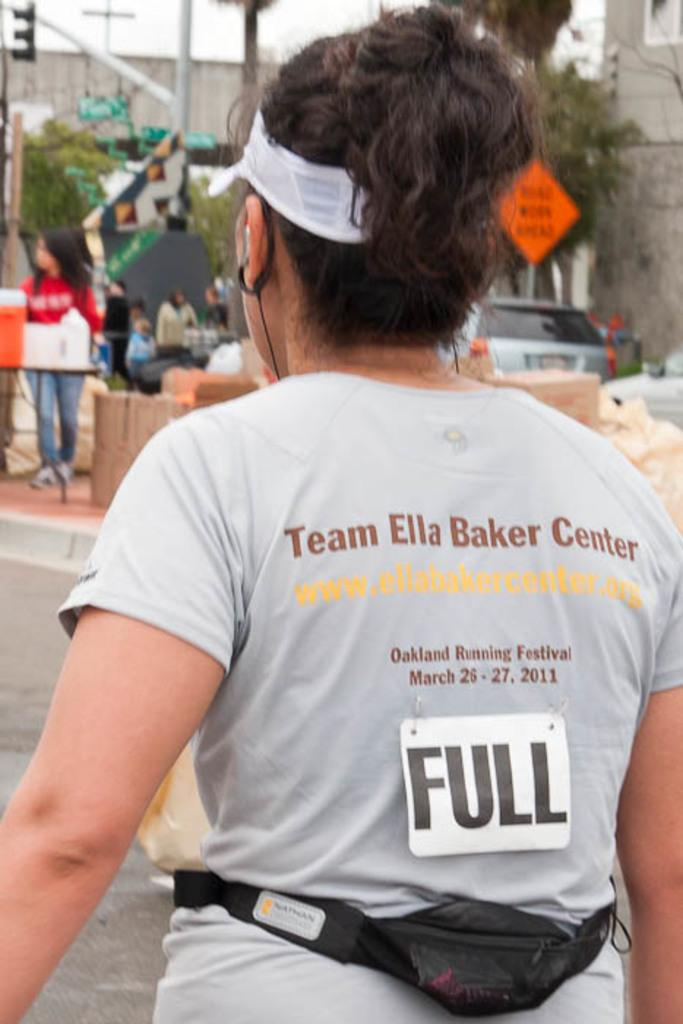<image>
Provide a brief description of the given image. A woman runner is wearing a Team Ella Baker Center shirt. 